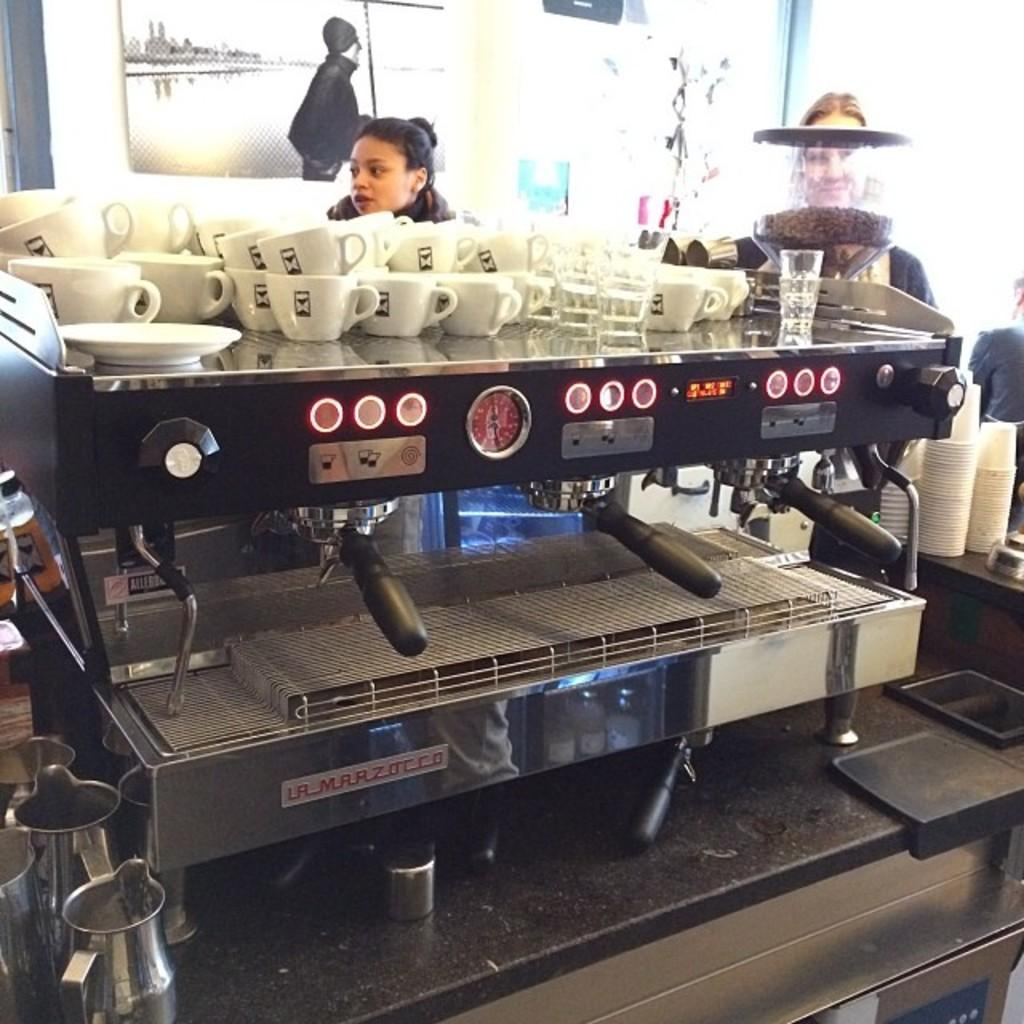Provide a one-sentence caption for the provided image. People are waiting in line behind a La Marzocco espresso machine. 